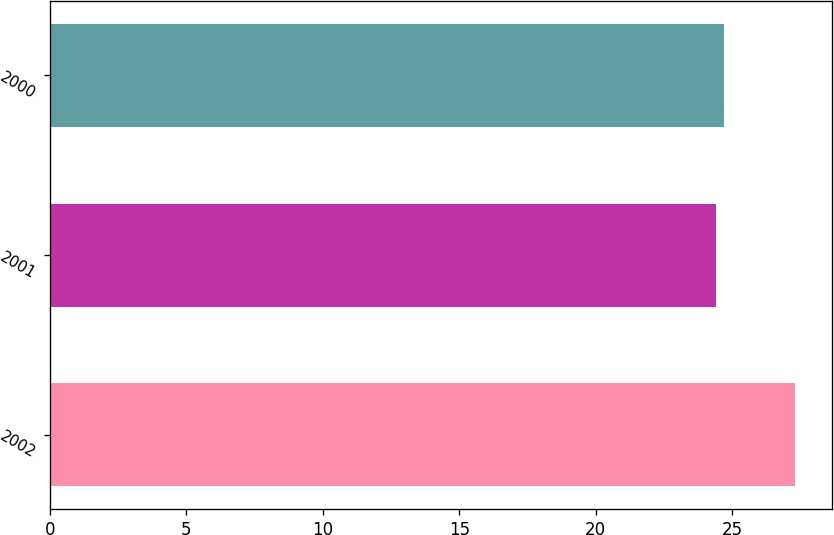<chart> <loc_0><loc_0><loc_500><loc_500><bar_chart><fcel>2002<fcel>2001<fcel>2000<nl><fcel>27.3<fcel>24.4<fcel>24.69<nl></chart> 